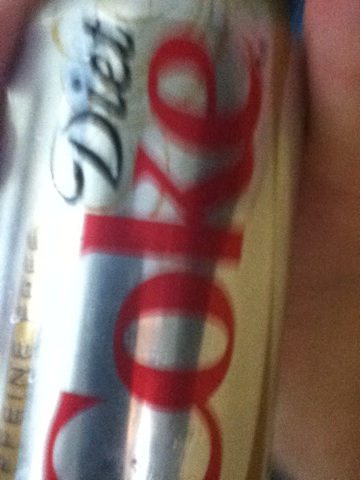Can you tell if the can is full or empty from the picture? It's difficult to ascertain whether the can is full or empty just by this image alone, as there are no clear indicators such as condensation or deformation that typically signify a can's state. For a precise answer, one would need to handle the can physically. 